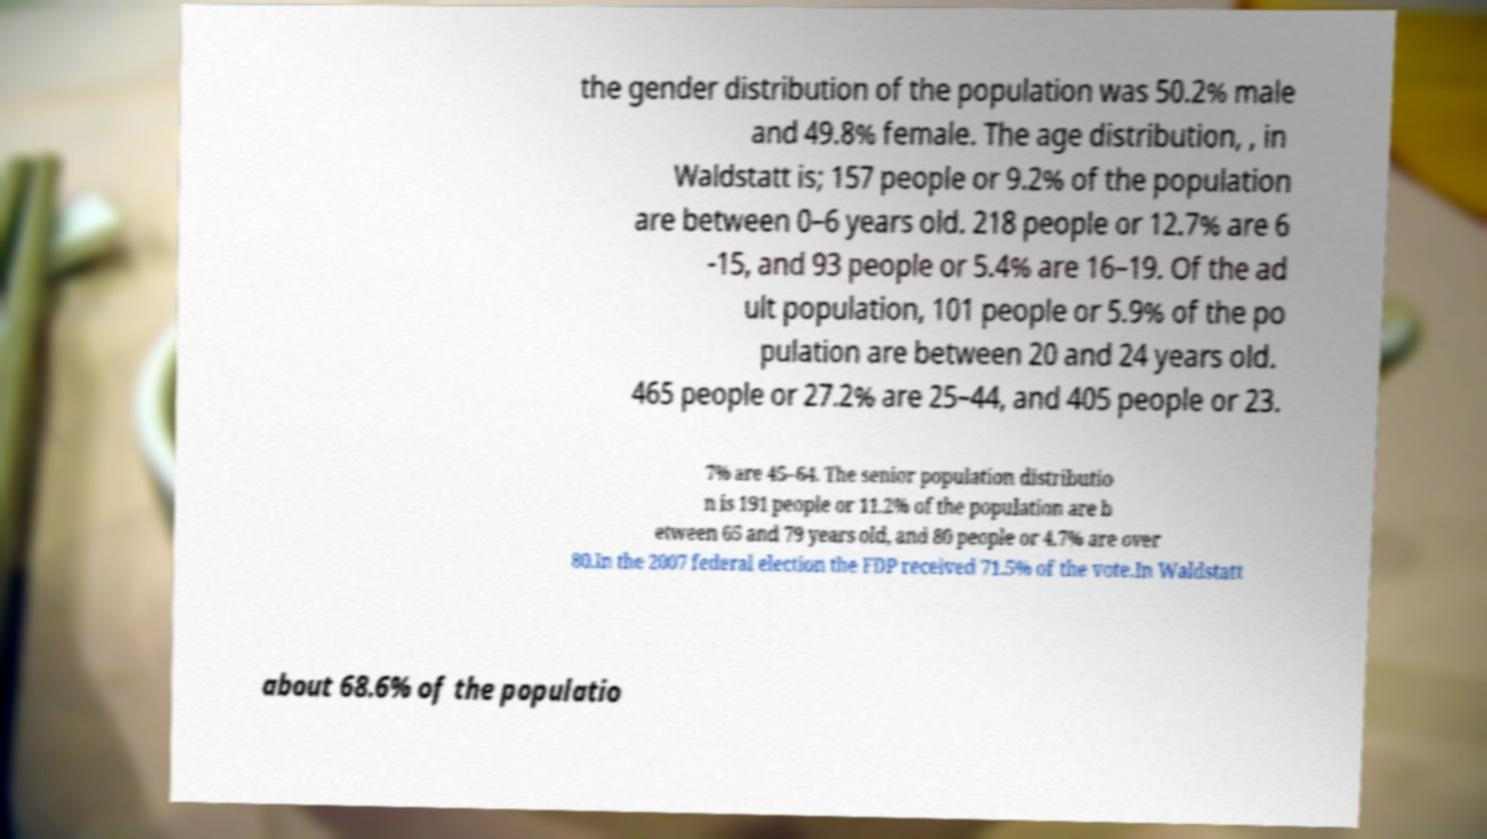Could you extract and type out the text from this image? the gender distribution of the population was 50.2% male and 49.8% female. The age distribution, , in Waldstatt is; 157 people or 9.2% of the population are between 0–6 years old. 218 people or 12.7% are 6 -15, and 93 people or 5.4% are 16–19. Of the ad ult population, 101 people or 5.9% of the po pulation are between 20 and 24 years old. 465 people or 27.2% are 25–44, and 405 people or 23. 7% are 45–64. The senior population distributio n is 191 people or 11.2% of the population are b etween 65 and 79 years old, and 80 people or 4.7% are over 80.In the 2007 federal election the FDP received 71.5% of the vote.In Waldstatt about 68.6% of the populatio 